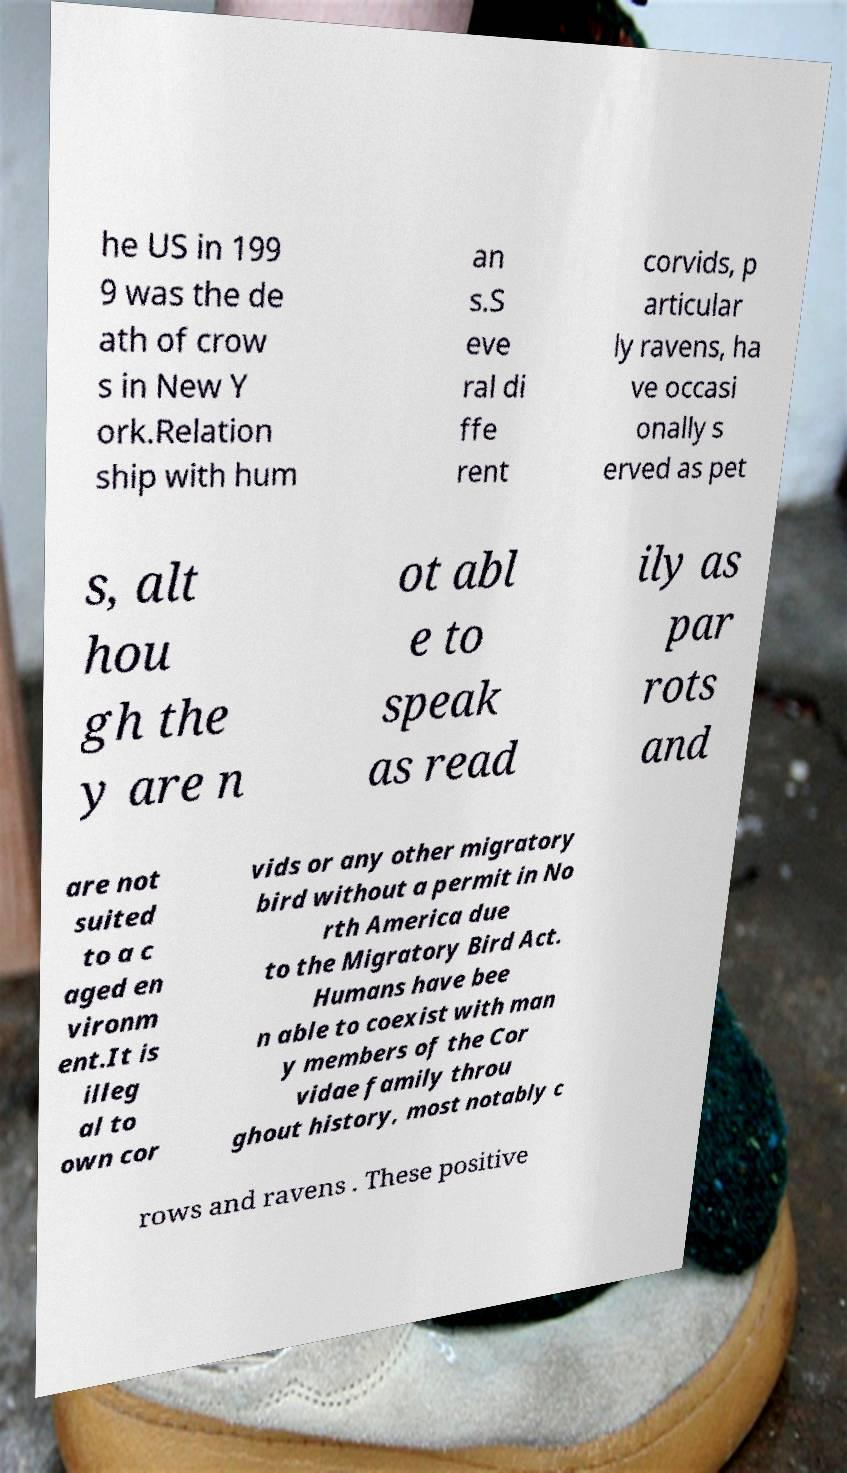Can you read and provide the text displayed in the image?This photo seems to have some interesting text. Can you extract and type it out for me? he US in 199 9 was the de ath of crow s in New Y ork.Relation ship with hum an s.S eve ral di ffe rent corvids, p articular ly ravens, ha ve occasi onally s erved as pet s, alt hou gh the y are n ot abl e to speak as read ily as par rots and are not suited to a c aged en vironm ent.It is illeg al to own cor vids or any other migratory bird without a permit in No rth America due to the Migratory Bird Act. Humans have bee n able to coexist with man y members of the Cor vidae family throu ghout history, most notably c rows and ravens . These positive 